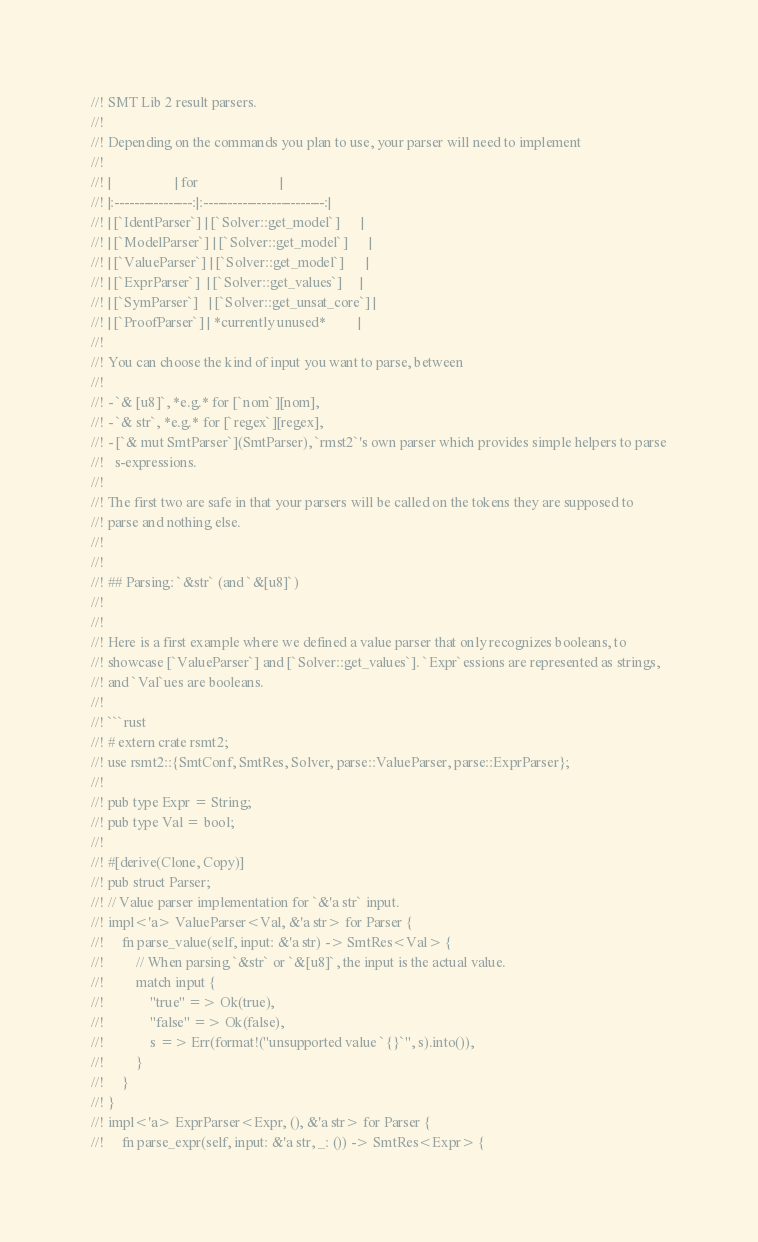Convert code to text. <code><loc_0><loc_0><loc_500><loc_500><_Rust_>//! SMT Lib 2 result parsers.
//!
//! Depending on the commands you plan to use, your parser will need to implement
//!
//! |                  | for                       |
//! |:----------------:|:-------------------------:|
//! | [`IdentParser`] | [`Solver::get_model`]      |
//! | [`ModelParser`] | [`Solver::get_model`]      |
//! | [`ValueParser`] | [`Solver::get_model`]      |
//! | [`ExprParser`]  | [`Solver::get_values`]     |
//! | [`SymParser`]   | [`Solver::get_unsat_core`] |
//! | [`ProofParser`] | *currently unused*         |
//!
//! You can choose the kind of input you want to parse, between
//!
//! - `& [u8]`, *e.g.* for [`nom`][nom],
//! - `& str`, *e.g.* for [`regex`][regex],
//! - [`& mut SmtParser`](SmtParser), `rmst2`'s own parser which provides simple helpers to parse
//!   s-expressions.
//!
//! The first two are safe in that your parsers will be called on the tokens they are supposed to
//! parse and nothing else.
//!
//!
//! ## Parsing: `&str` (and `&[u8]`)
//!
//!
//! Here is a first example where we defined a value parser that only recognizes booleans, to
//! showcase [`ValueParser`] and [`Solver::get_values`]. `Expr`essions are represented as strings,
//! and `Val`ues are booleans.
//!
//! ```rust
//! # extern crate rsmt2;
//! use rsmt2::{SmtConf, SmtRes, Solver, parse::ValueParser, parse::ExprParser};
//!
//! pub type Expr = String;
//! pub type Val = bool;
//!
//! #[derive(Clone, Copy)]
//! pub struct Parser;
//! // Value parser implementation for `&'a str` input.
//! impl<'a> ValueParser<Val, &'a str> for Parser {
//!     fn parse_value(self, input: &'a str) -> SmtRes<Val> {
//!         // When parsing `&str` or `&[u8]`, the input is the actual value.
//!         match input {
//!             "true" => Ok(true),
//!             "false" => Ok(false),
//!             s => Err(format!("unsupported value `{}`", s).into()),
//!         }
//!     }
//! }
//! impl<'a> ExprParser<Expr, (), &'a str> for Parser {
//!     fn parse_expr(self, input: &'a str, _: ()) -> SmtRes<Expr> {</code> 